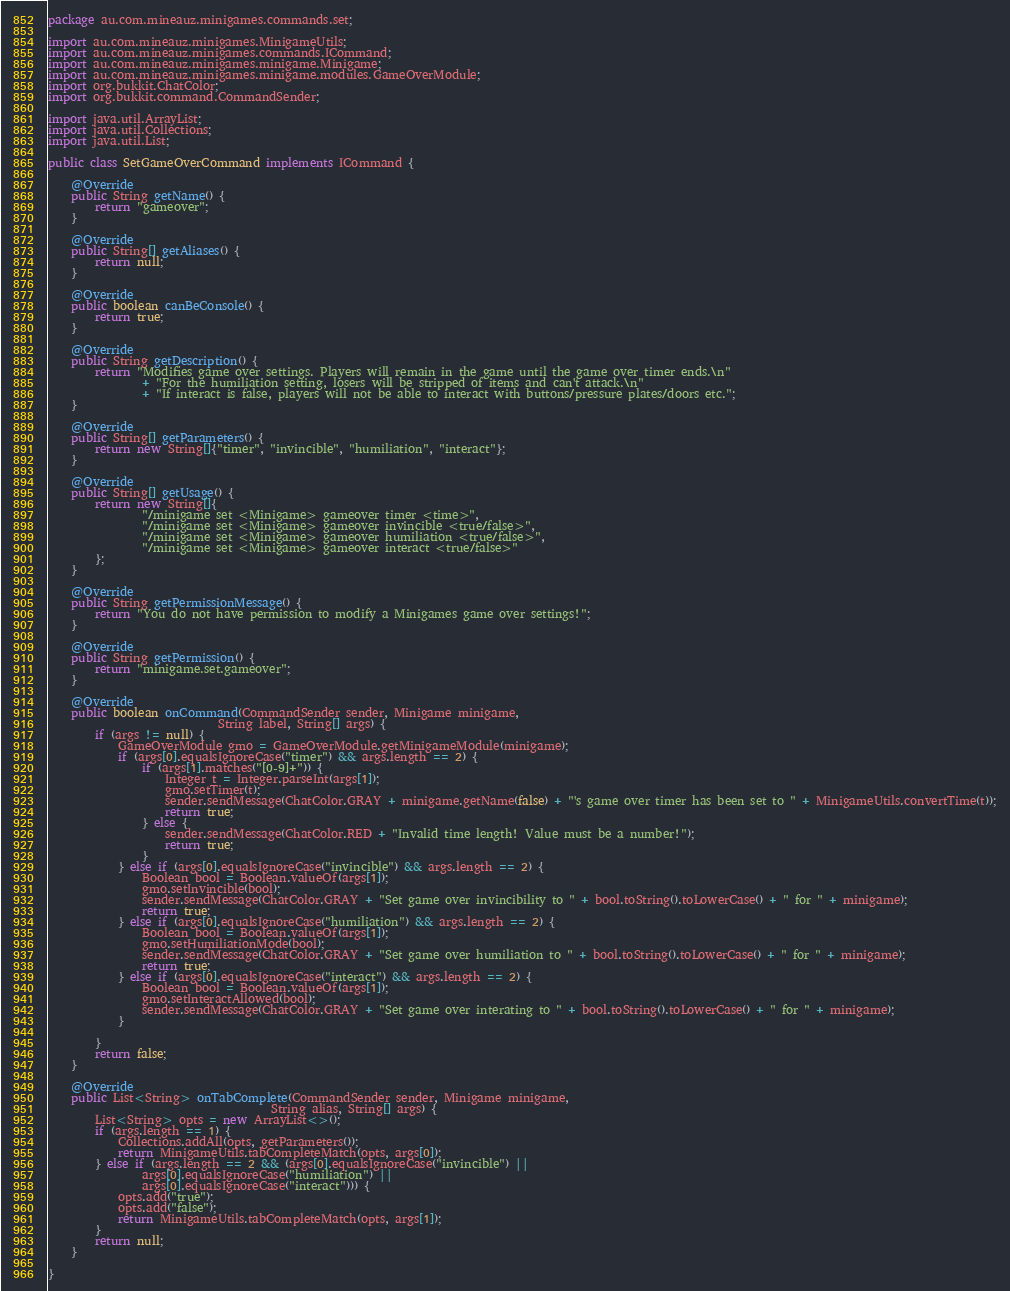<code> <loc_0><loc_0><loc_500><loc_500><_Java_>package au.com.mineauz.minigames.commands.set;

import au.com.mineauz.minigames.MinigameUtils;
import au.com.mineauz.minigames.commands.ICommand;
import au.com.mineauz.minigames.minigame.Minigame;
import au.com.mineauz.minigames.minigame.modules.GameOverModule;
import org.bukkit.ChatColor;
import org.bukkit.command.CommandSender;

import java.util.ArrayList;
import java.util.Collections;
import java.util.List;

public class SetGameOverCommand implements ICommand {

    @Override
    public String getName() {
        return "gameover";
    }

    @Override
    public String[] getAliases() {
        return null;
    }

    @Override
    public boolean canBeConsole() {
        return true;
    }

    @Override
    public String getDescription() {
        return "Modifies game over settings. Players will remain in the game until the game over timer ends.\n"
                + "For the humiliation setting, losers will be stripped of items and can't attack.\n"
                + "If interact is false, players will not be able to interact with buttons/pressure plates/doors etc.";
    }

    @Override
    public String[] getParameters() {
        return new String[]{"timer", "invincible", "humiliation", "interact"};
    }

    @Override
    public String[] getUsage() {
        return new String[]{
                "/minigame set <Minigame> gameover timer <time>",
                "/minigame set <Minigame> gameover invincible <true/false>",
                "/minigame set <Minigame> gameover humiliation <true/false>",
                "/minigame set <Minigame> gameover interact <true/false>"
        };
    }

    @Override
    public String getPermissionMessage() {
        return "You do not have permission to modify a Minigames game over settings!";
    }

    @Override
    public String getPermission() {
        return "minigame.set.gameover";
    }

    @Override
    public boolean onCommand(CommandSender sender, Minigame minigame,
                             String label, String[] args) {
        if (args != null) {
            GameOverModule gmo = GameOverModule.getMinigameModule(minigame);
            if (args[0].equalsIgnoreCase("timer") && args.length == 2) {
                if (args[1].matches("[0-9]+")) {
                    Integer t = Integer.parseInt(args[1]);
                    gmo.setTimer(t);
                    sender.sendMessage(ChatColor.GRAY + minigame.getName(false) + "'s game over timer has been set to " + MinigameUtils.convertTime(t));
                    return true;
                } else {
                    sender.sendMessage(ChatColor.RED + "Invalid time length! Value must be a number!");
                    return true;
                }
            } else if (args[0].equalsIgnoreCase("invincible") && args.length == 2) {
                Boolean bool = Boolean.valueOf(args[1]);
                gmo.setInvincible(bool);
                sender.sendMessage(ChatColor.GRAY + "Set game over invincibility to " + bool.toString().toLowerCase() + " for " + minigame);
                return true;
            } else if (args[0].equalsIgnoreCase("humiliation") && args.length == 2) {
                Boolean bool = Boolean.valueOf(args[1]);
                gmo.setHumiliationMode(bool);
                sender.sendMessage(ChatColor.GRAY + "Set game over humiliation to " + bool.toString().toLowerCase() + " for " + minigame);
                return true;
            } else if (args[0].equalsIgnoreCase("interact") && args.length == 2) {
                Boolean bool = Boolean.valueOf(args[1]);
                gmo.setInteractAllowed(bool);
                sender.sendMessage(ChatColor.GRAY + "Set game over interating to " + bool.toString().toLowerCase() + " for " + minigame);
            }

        }
        return false;
    }

    @Override
    public List<String> onTabComplete(CommandSender sender, Minigame minigame,
                                      String alias, String[] args) {
        List<String> opts = new ArrayList<>();
        if (args.length == 1) {
            Collections.addAll(opts, getParameters());
            return MinigameUtils.tabCompleteMatch(opts, args[0]);
        } else if (args.length == 2 && (args[0].equalsIgnoreCase("invincible") ||
                args[0].equalsIgnoreCase("humiliation") ||
                args[0].equalsIgnoreCase("interact"))) {
            opts.add("true");
            opts.add("false");
            return MinigameUtils.tabCompleteMatch(opts, args[1]);
        }
        return null;
    }

}
</code> 